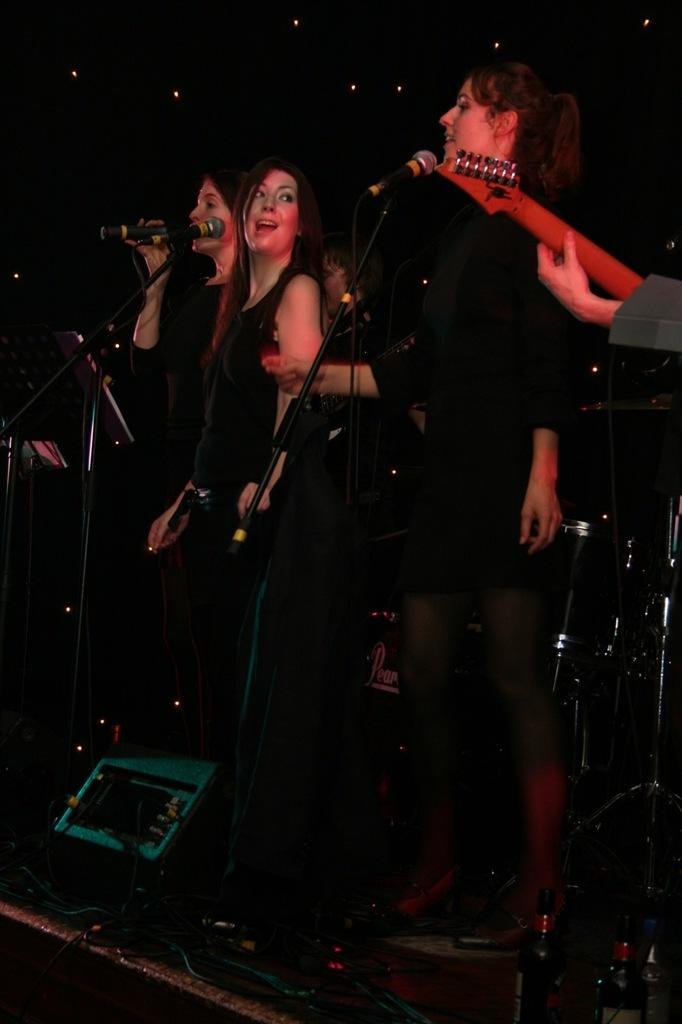What are the persons in the image doing? The persons in the image are standing in front of a microphone. What else can be seen in the image besides the persons and the microphone? There are bottles visible in the image. What type of bread is being used to talk into the microphone in the image? There is no bread present in the image, and bread is not used to talk into a microphone. 